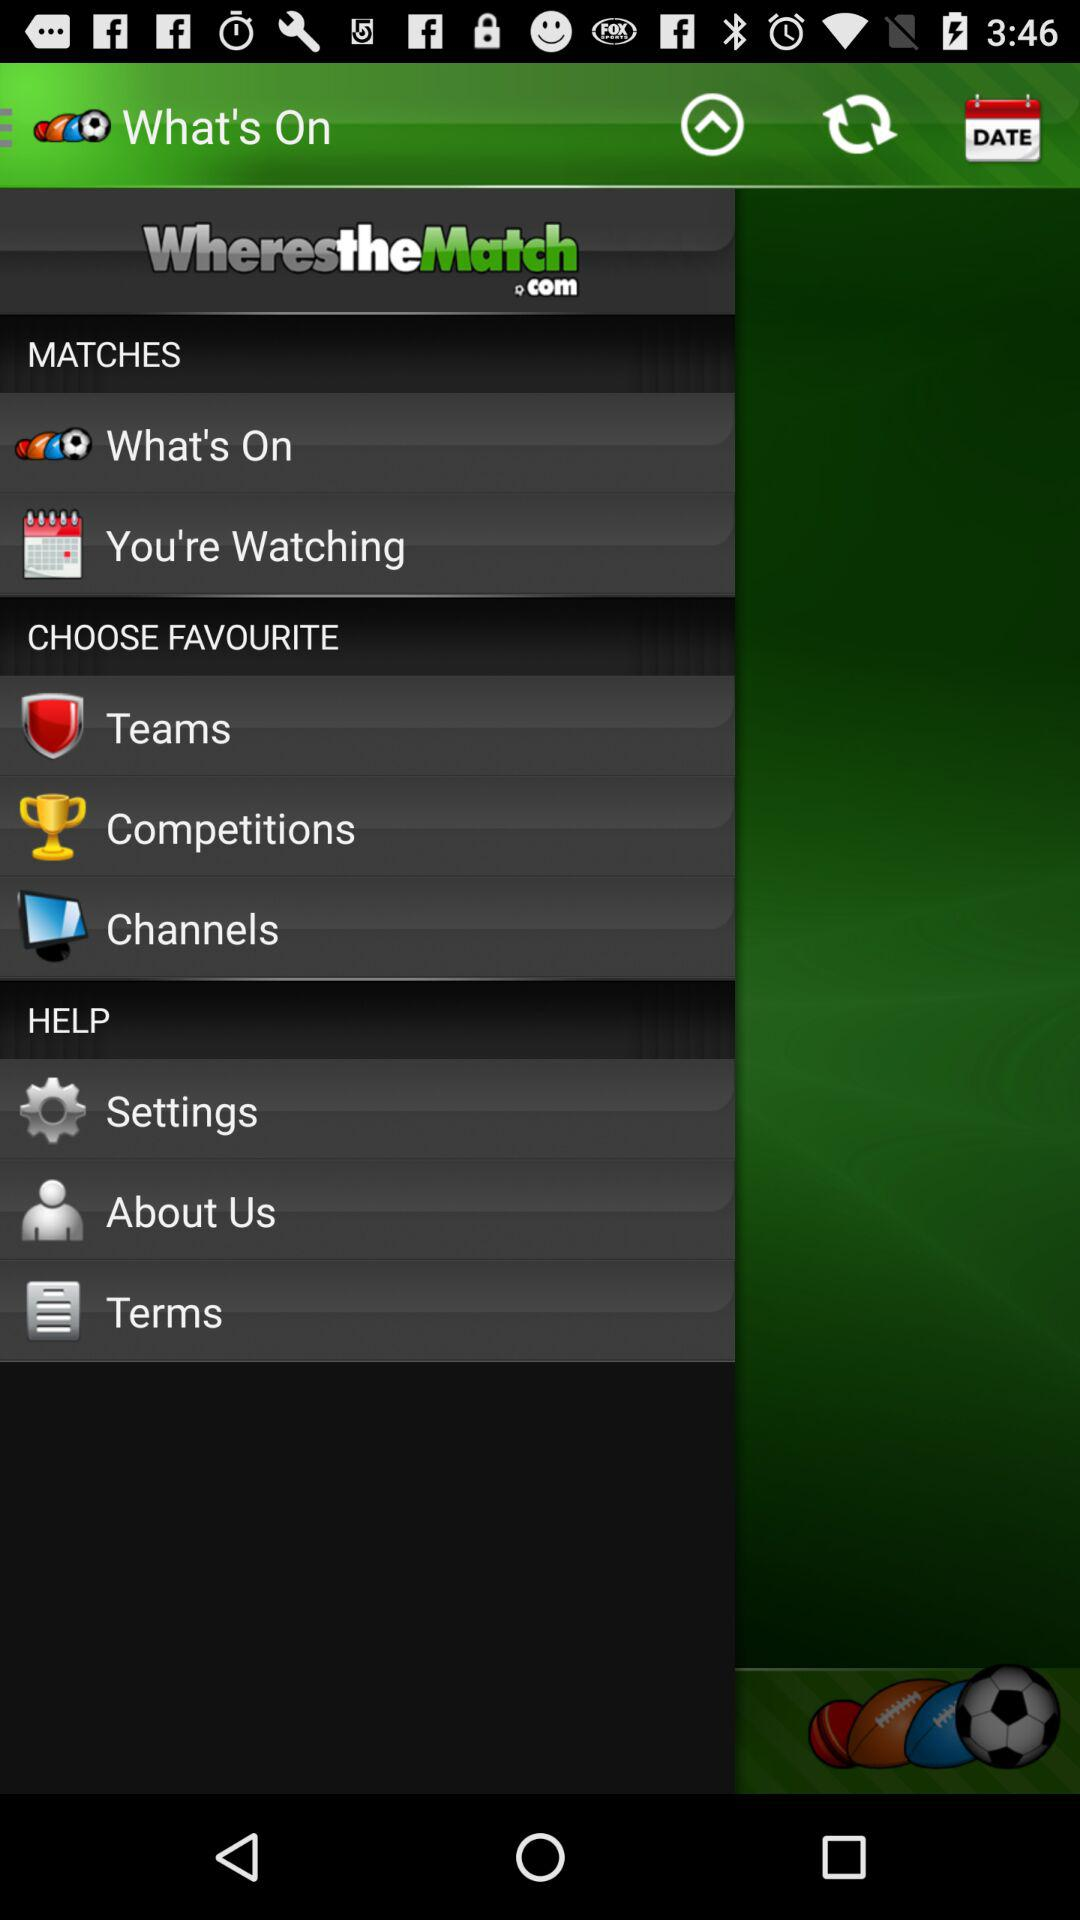What is the application Name? The application name is "WherestheMatch.com". 